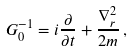Convert formula to latex. <formula><loc_0><loc_0><loc_500><loc_500>G _ { 0 } ^ { - 1 } = i \frac { \partial } { \partial t } + \frac { \nabla _ { r } ^ { 2 } } { 2 m } \, ,</formula> 